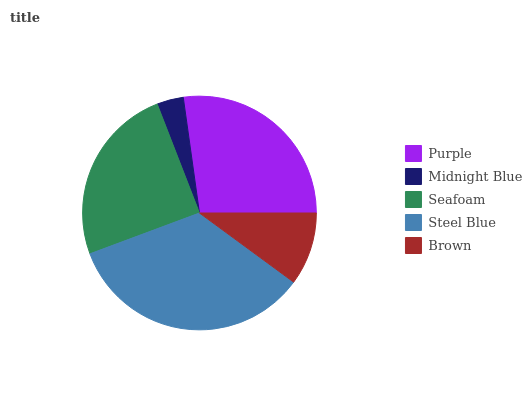Is Midnight Blue the minimum?
Answer yes or no. Yes. Is Steel Blue the maximum?
Answer yes or no. Yes. Is Seafoam the minimum?
Answer yes or no. No. Is Seafoam the maximum?
Answer yes or no. No. Is Seafoam greater than Midnight Blue?
Answer yes or no. Yes. Is Midnight Blue less than Seafoam?
Answer yes or no. Yes. Is Midnight Blue greater than Seafoam?
Answer yes or no. No. Is Seafoam less than Midnight Blue?
Answer yes or no. No. Is Seafoam the high median?
Answer yes or no. Yes. Is Seafoam the low median?
Answer yes or no. Yes. Is Purple the high median?
Answer yes or no. No. Is Brown the low median?
Answer yes or no. No. 